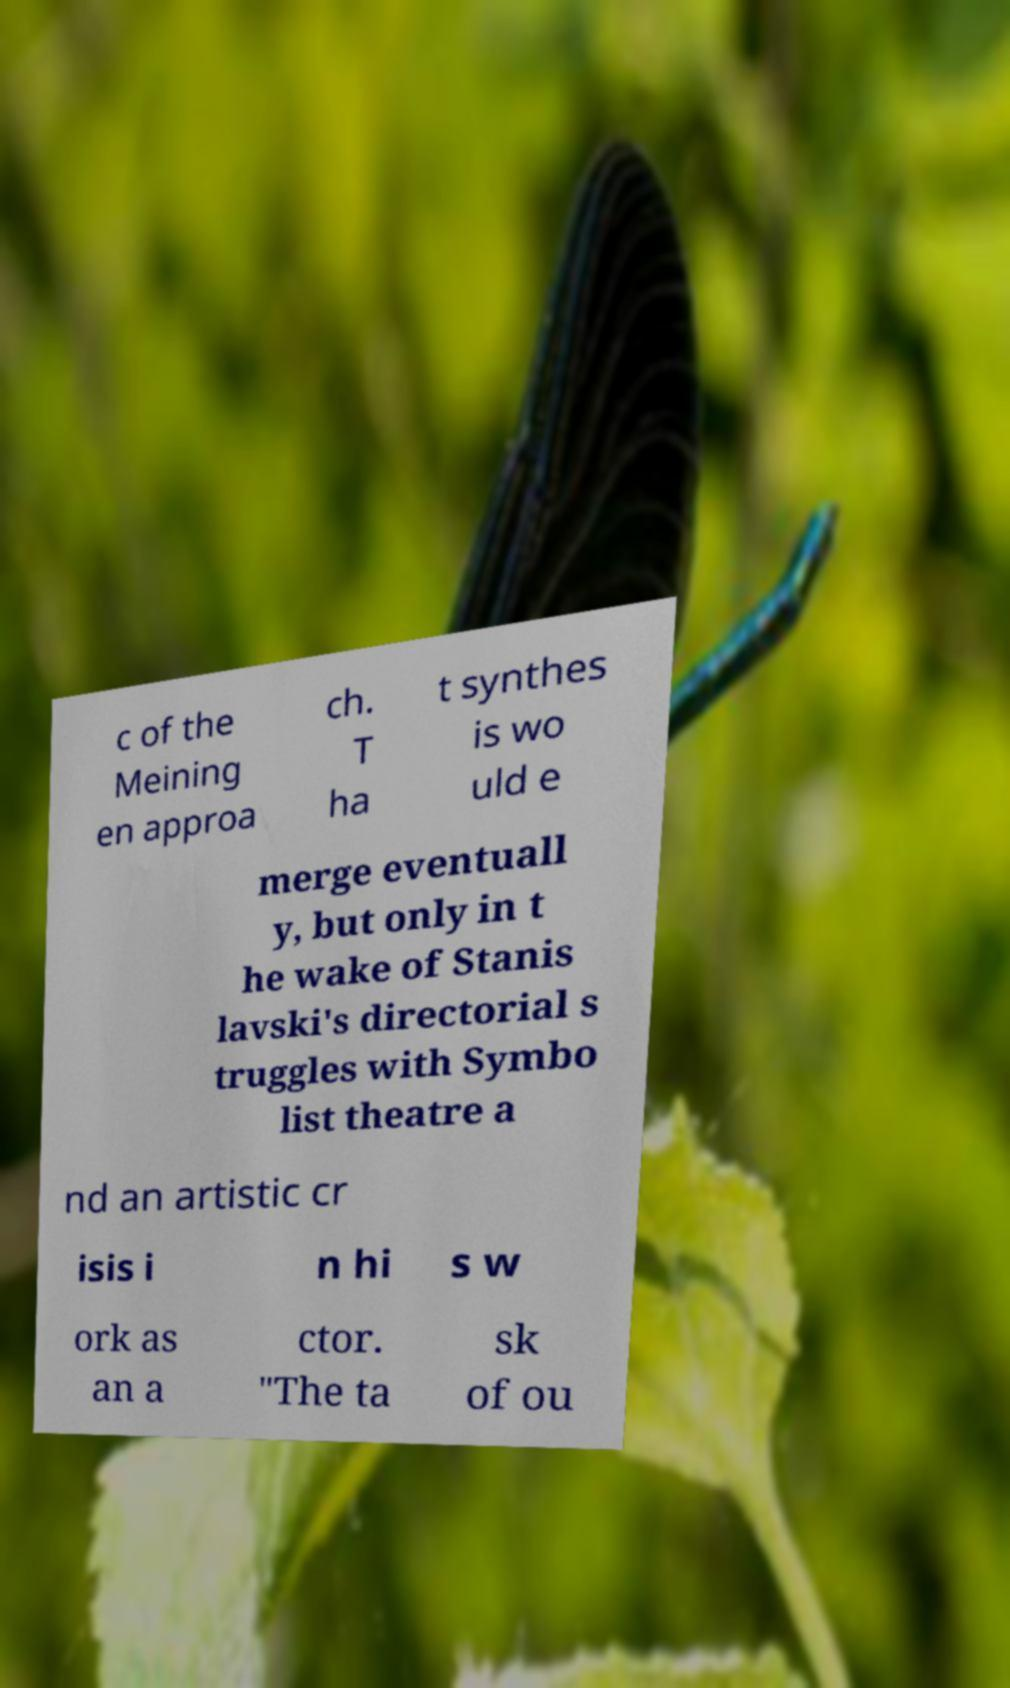Could you extract and type out the text from this image? c of the Meining en approa ch. T ha t synthes is wo uld e merge eventuall y, but only in t he wake of Stanis lavski's directorial s truggles with Symbo list theatre a nd an artistic cr isis i n hi s w ork as an a ctor. "The ta sk of ou 